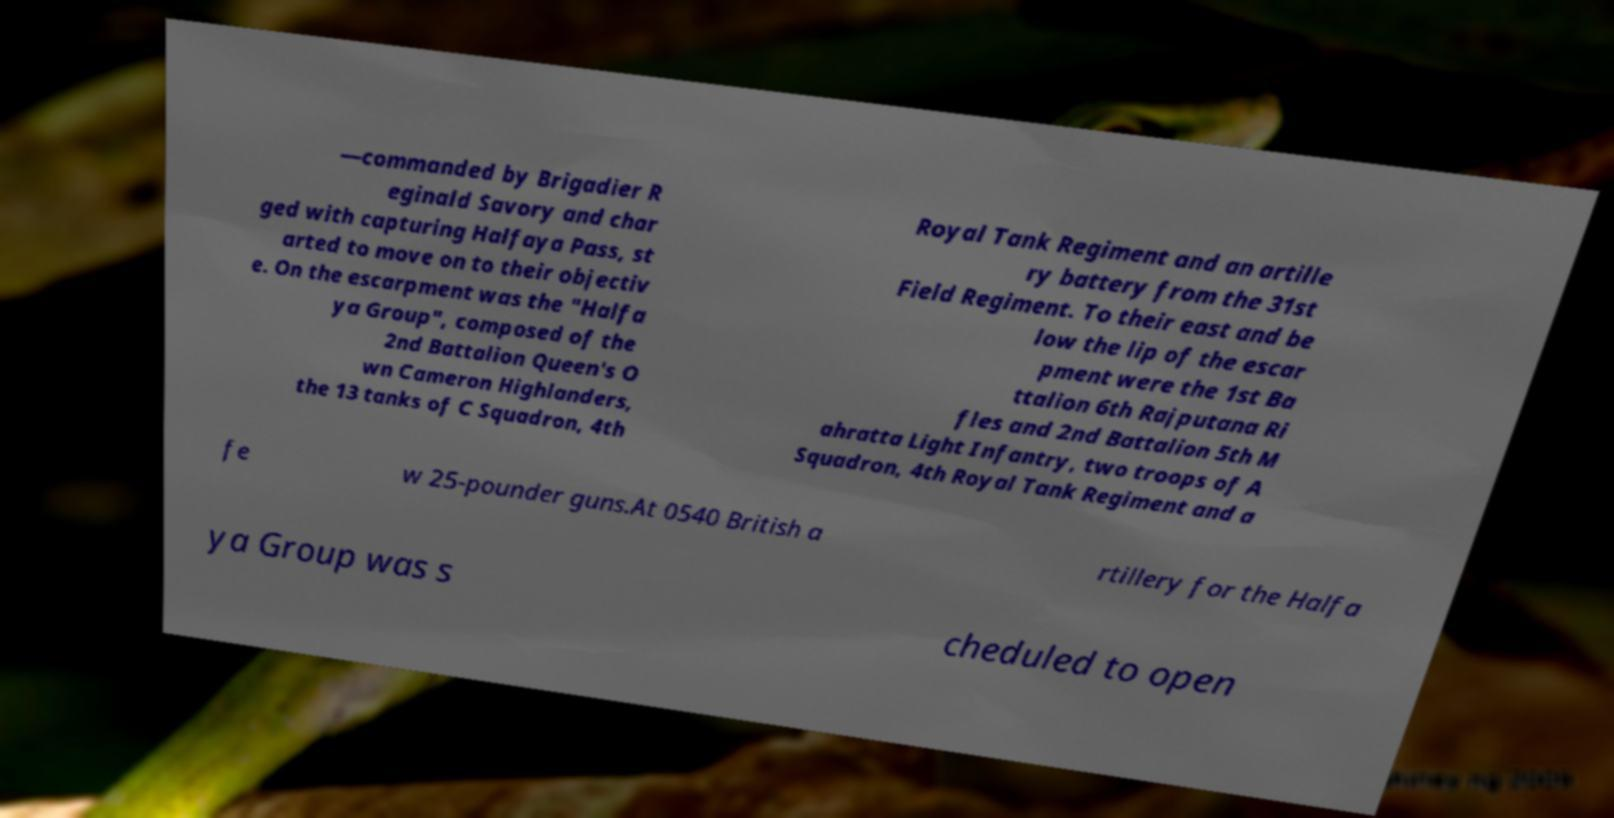Could you extract and type out the text from this image? —commanded by Brigadier R eginald Savory and char ged with capturing Halfaya Pass, st arted to move on to their objectiv e. On the escarpment was the "Halfa ya Group", composed of the 2nd Battalion Queen's O wn Cameron Highlanders, the 13 tanks of C Squadron, 4th Royal Tank Regiment and an artille ry battery from the 31st Field Regiment. To their east and be low the lip of the escar pment were the 1st Ba ttalion 6th Rajputana Ri fles and 2nd Battalion 5th M ahratta Light Infantry, two troops of A Squadron, 4th Royal Tank Regiment and a fe w 25-pounder guns.At 0540 British a rtillery for the Halfa ya Group was s cheduled to open 